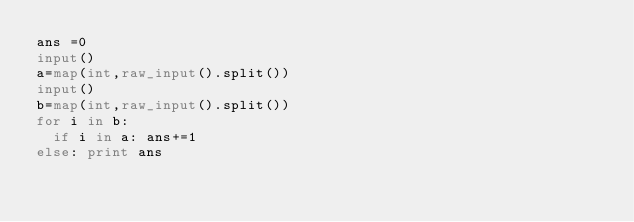Convert code to text. <code><loc_0><loc_0><loc_500><loc_500><_Python_>ans =0
input()
a=map(int,raw_input().split())
input()
b=map(int,raw_input().split())
for i in b:
  if i in a: ans+=1
else: print ans</code> 